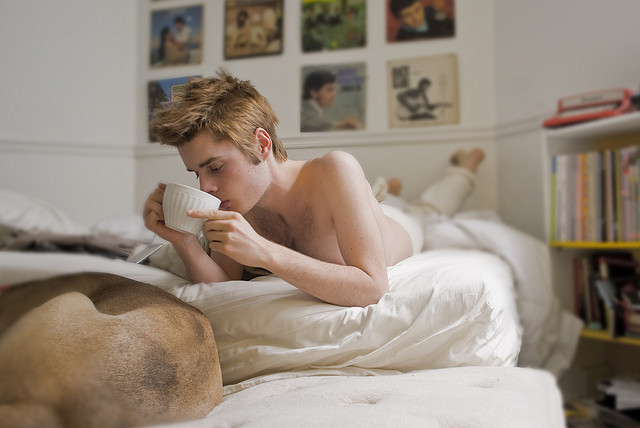<image>Where is the other eye? The other eye is out of view or it can be on the other side of the head, turned away from the camera, or out of the frame. What is the dog doing on the couch? I don't know what the dog is doing on the couch. It could be sleeping or laying. Where is the other eye? It is unclear where the other eye is. It could be out of view, hidden, or on the other side of the head. What is the dog doing on the couch? It can be seen that the dog is sleeping on the couch. 